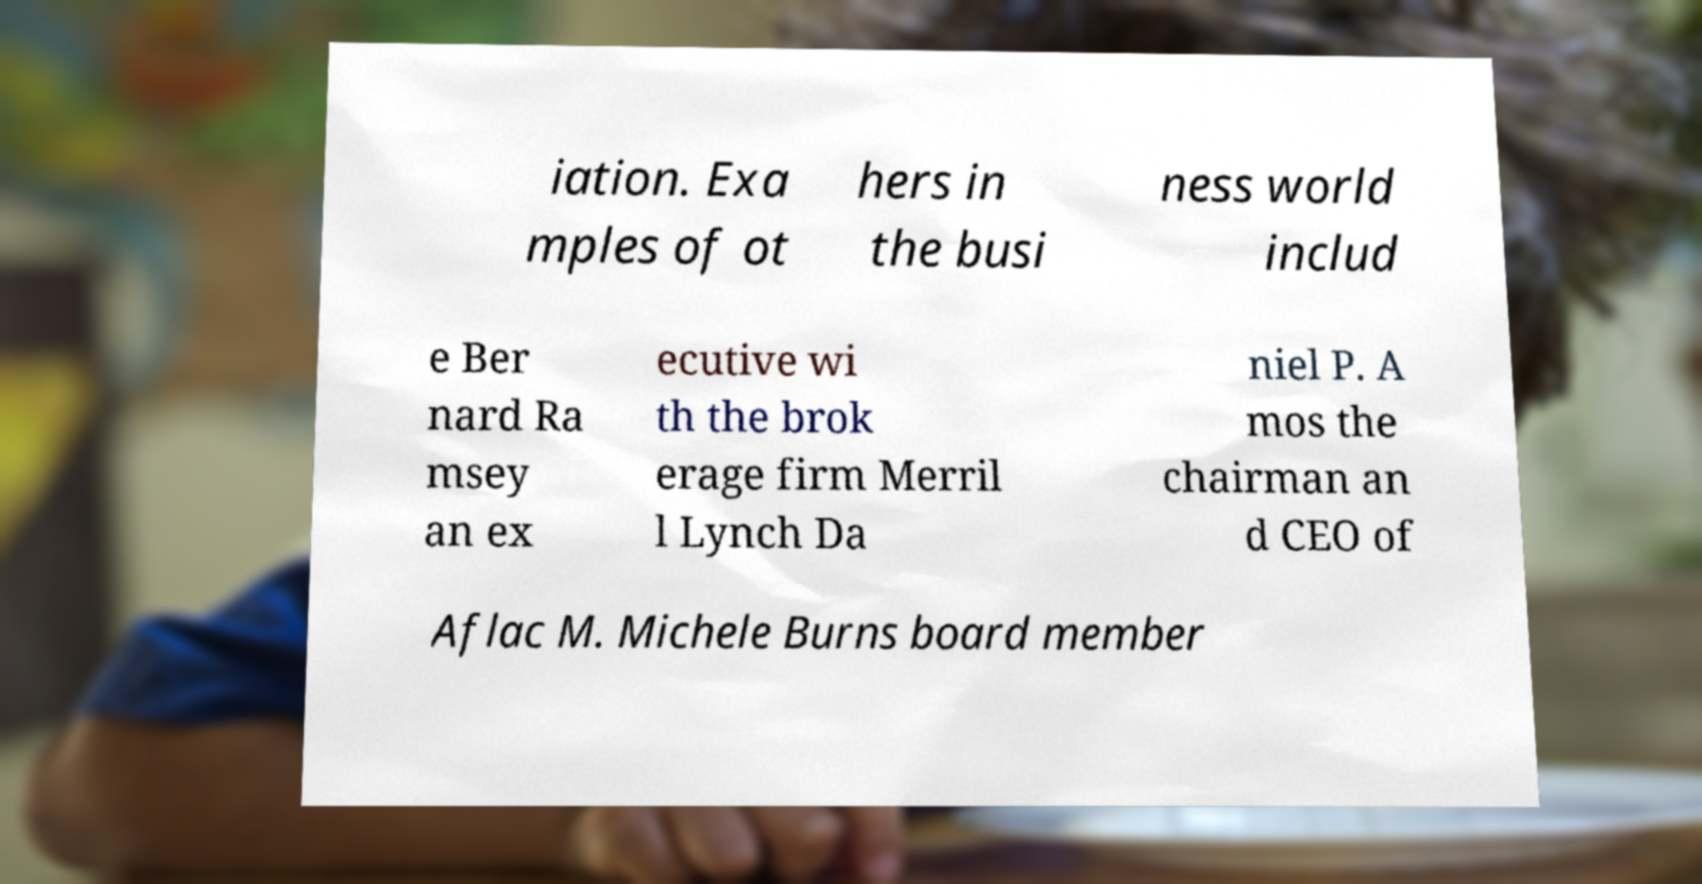I need the written content from this picture converted into text. Can you do that? iation. Exa mples of ot hers in the busi ness world includ e Ber nard Ra msey an ex ecutive wi th the brok erage firm Merril l Lynch Da niel P. A mos the chairman an d CEO of Aflac M. Michele Burns board member 